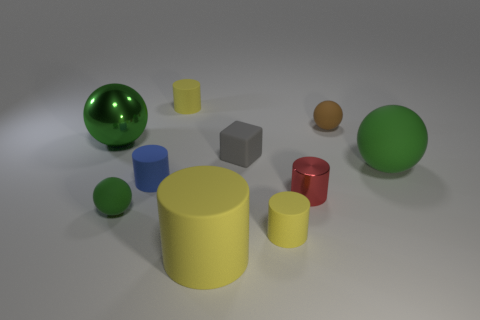Do the shiny cylinder and the gray block have the same size?
Your response must be concise. Yes. How many large yellow objects have the same material as the small green ball?
Offer a terse response. 1. What size is the brown thing that is the same shape as the green metal object?
Your answer should be very brief. Small. Is the shape of the big green thing in front of the large green metallic thing the same as  the blue object?
Your answer should be very brief. No. What shape is the tiny yellow thing in front of the tiny yellow matte object behind the blue matte cylinder?
Your answer should be compact. Cylinder. Is there anything else that has the same shape as the tiny green object?
Ensure brevity in your answer.  Yes. What is the color of the other large thing that is the same shape as the red shiny thing?
Make the answer very short. Yellow. There is a metallic sphere; is it the same color as the shiny object that is on the right side of the gray object?
Offer a terse response. No. What is the shape of the object that is both behind the block and in front of the brown sphere?
Offer a very short reply. Sphere. Are there fewer large blue metallic balls than red cylinders?
Your answer should be very brief. Yes. 